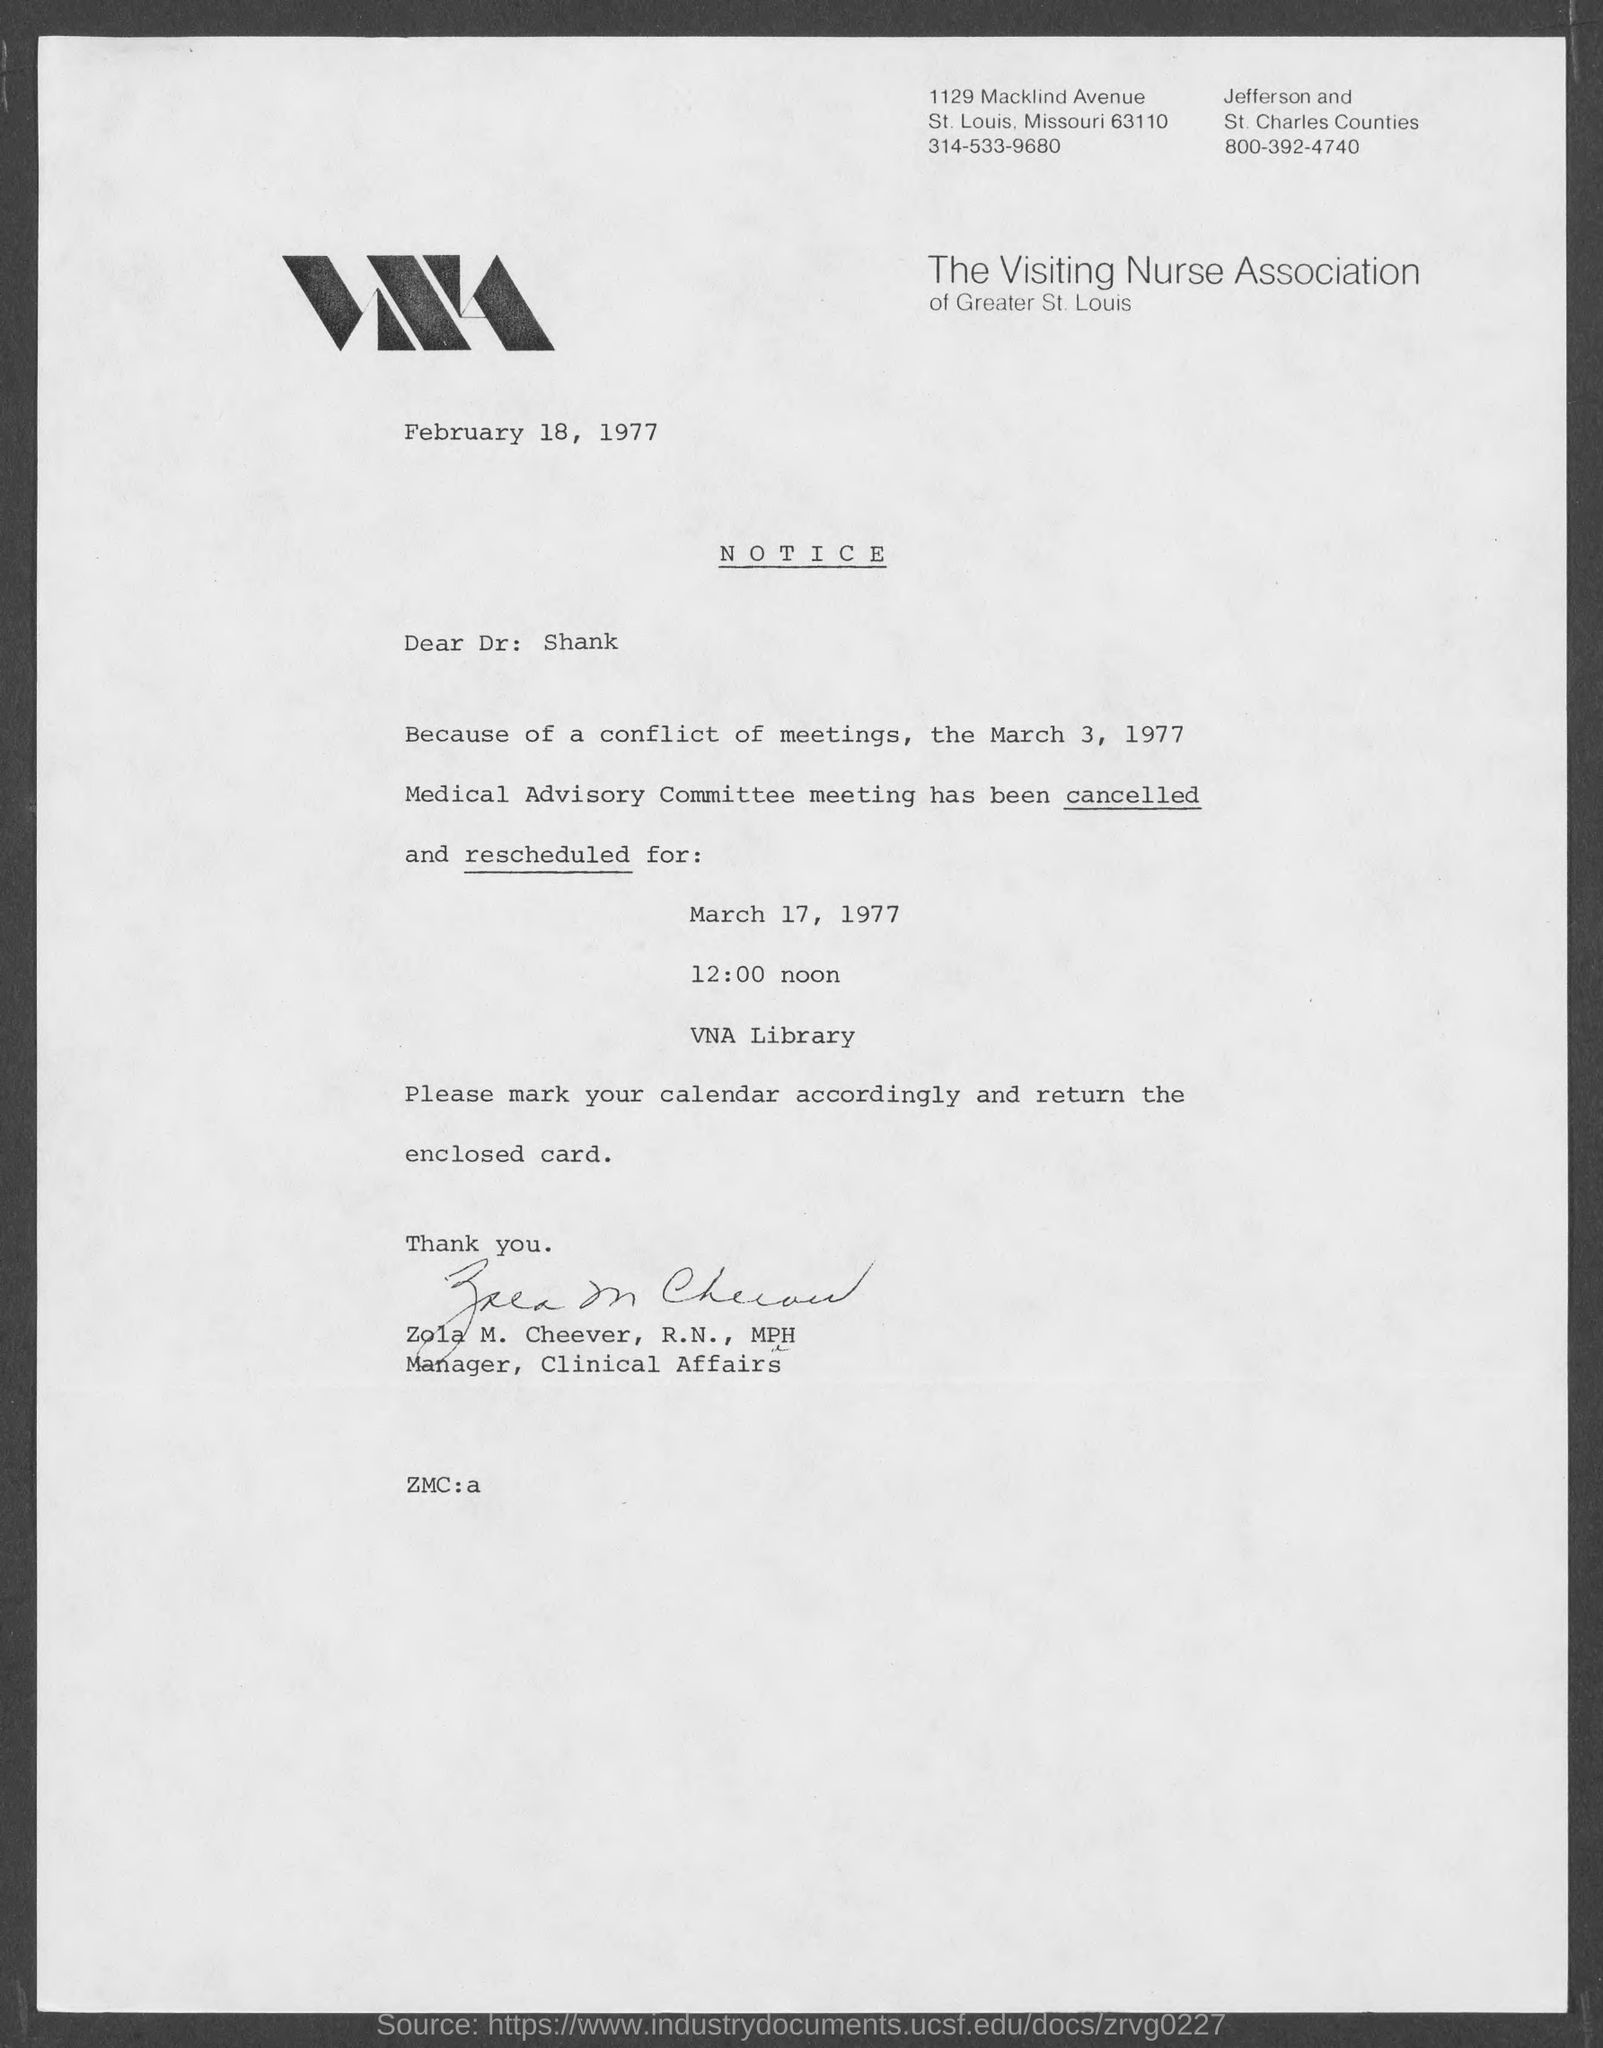What is the date mentioned in the top of the document ?
Ensure brevity in your answer.  February 18, 1977. Who is the memorandum from ?
Your answer should be compact. Zola M. Cheever,. 